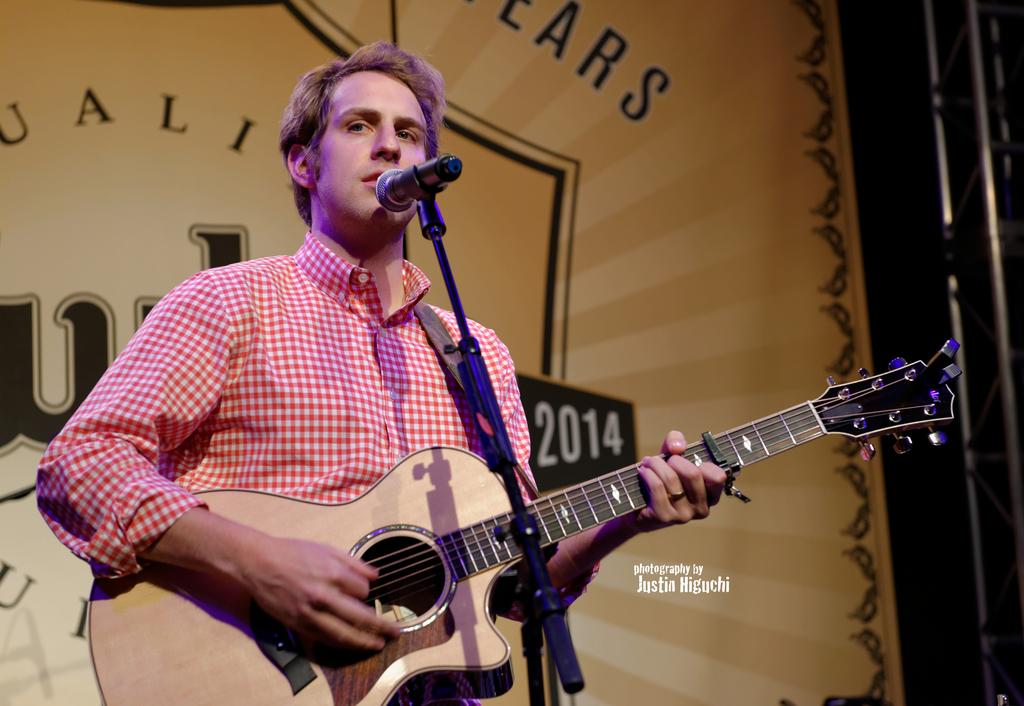What is the main subject of the image? The main subject of the image is a man. What is the man wearing in the image? The man is wearing a shirt in the image. What object is the man holding in the image? The man is holding a guitar in the image. What device is present in the image for amplifying sound? There is a microphone in the image. Is there any text or logo visible in the image? Yes, there is a watermark in the image. What type of hose can be seen in the image? There is no hose present in the image. What town is depicted in the background of the image? The image does not show a town or any background; it is focused on the man and his guitar. 